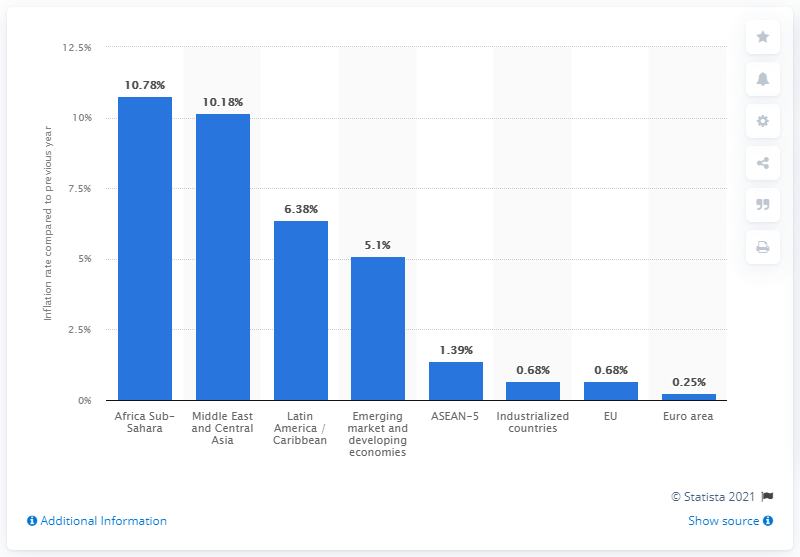Mention a couple of crucial points in this snapshot. In 2020, the inflation rate of industrialized countries was 0.68%. 